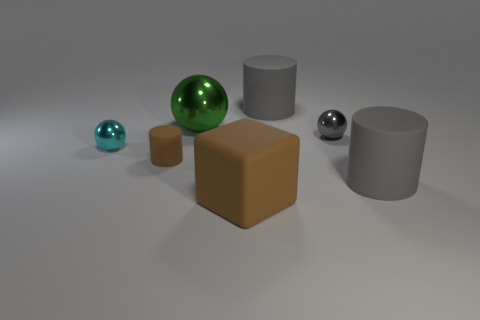What's the possible size comparison between the turquoise and the green spheres? The turquoise sphere appears to be smaller than the green one, potentially around half its size or somewhat larger. This size difference helps create a sense of scale and dimension within the image. 